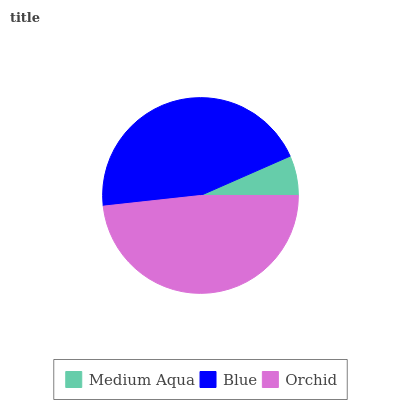Is Medium Aqua the minimum?
Answer yes or no. Yes. Is Orchid the maximum?
Answer yes or no. Yes. Is Blue the minimum?
Answer yes or no. No. Is Blue the maximum?
Answer yes or no. No. Is Blue greater than Medium Aqua?
Answer yes or no. Yes. Is Medium Aqua less than Blue?
Answer yes or no. Yes. Is Medium Aqua greater than Blue?
Answer yes or no. No. Is Blue less than Medium Aqua?
Answer yes or no. No. Is Blue the high median?
Answer yes or no. Yes. Is Blue the low median?
Answer yes or no. Yes. Is Medium Aqua the high median?
Answer yes or no. No. Is Medium Aqua the low median?
Answer yes or no. No. 